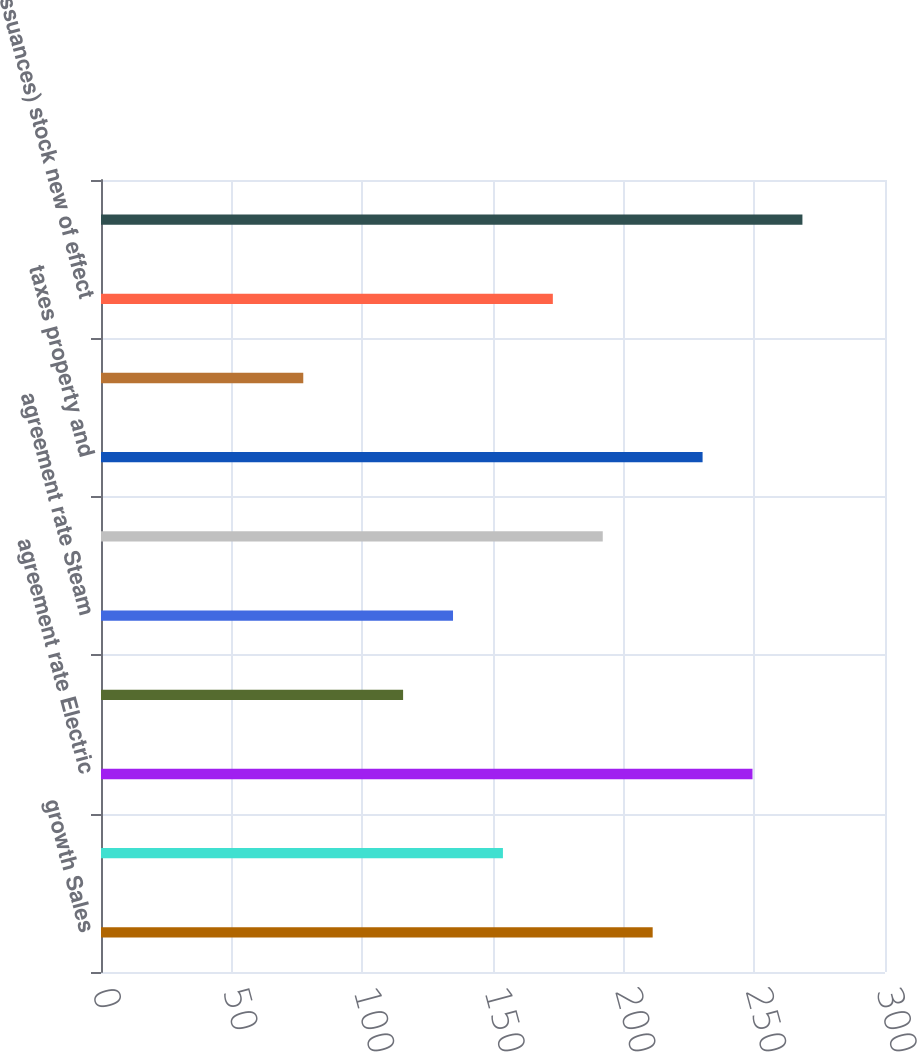Convert chart to OTSL. <chart><loc_0><loc_0><loc_500><loc_500><bar_chart><fcel>growth Sales<fcel>weather of Impact<fcel>agreement rate Electric<fcel>agreement rate Gas<fcel>agreement rate Steam<fcel>expense maintenance and<fcel>taxes property and<fcel>charges Interest<fcel>issuances) stock new of effect<fcel>York New of Edison Con Total<nl><fcel>211.1<fcel>153.8<fcel>249.3<fcel>115.6<fcel>134.7<fcel>192<fcel>230.2<fcel>77.4<fcel>172.9<fcel>268.4<nl></chart> 